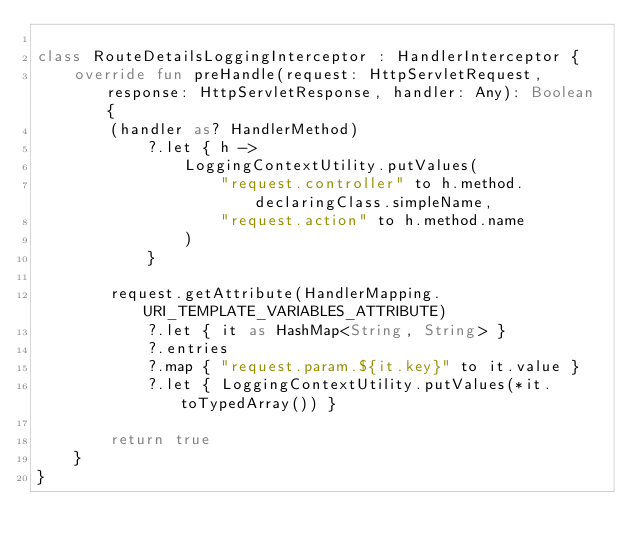Convert code to text. <code><loc_0><loc_0><loc_500><loc_500><_Kotlin_>
class RouteDetailsLoggingInterceptor : HandlerInterceptor {
    override fun preHandle(request: HttpServletRequest, response: HttpServletResponse, handler: Any): Boolean {
        (handler as? HandlerMethod)
            ?.let { h ->
                LoggingContextUtility.putValues(
                    "request.controller" to h.method.declaringClass.simpleName,
                    "request.action" to h.method.name
                )
            }

        request.getAttribute(HandlerMapping.URI_TEMPLATE_VARIABLES_ATTRIBUTE)
            ?.let { it as HashMap<String, String> }
            ?.entries
            ?.map { "request.param.${it.key}" to it.value }
            ?.let { LoggingContextUtility.putValues(*it.toTypedArray()) }

        return true
    }
}</code> 